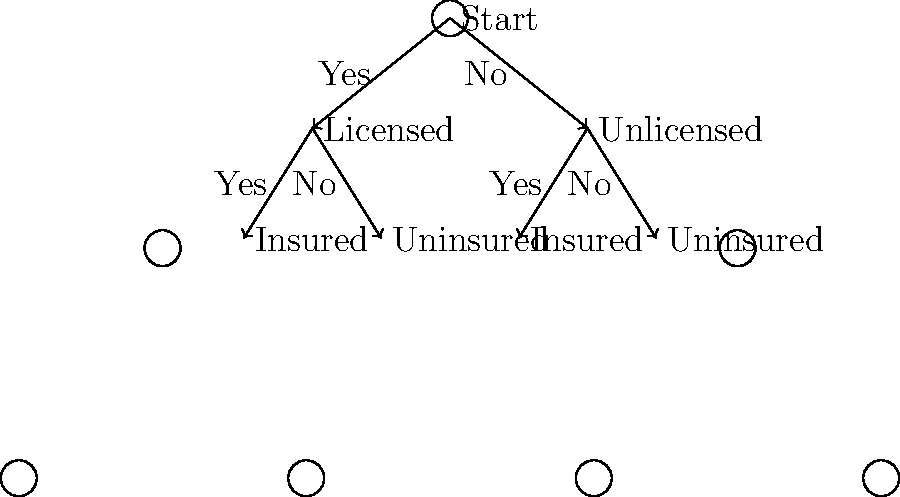Based on the decision tree for selecting trustworthy service providers, what is the optimal path to choose a provider, and how many criteria are considered in this selection process? To determine the optimal path and the number of criteria considered in the selection process, let's analyze the decision tree step-by-step:

1. The decision tree starts with two main criteria:
   a) Whether the service provider is licensed
   b) Whether the service provider is insured

2. The first decision point is about licensing:
   - If the provider is licensed, we move to the left branch
   - If the provider is unlicensed, we move to the right branch

3. The second decision point is about insurance:
   - For both licensed and unlicensed providers, we consider whether they are insured or not

4. The optimal path in this decision tree would be:
   Start → Licensed (Yes) → Insured (Yes)

5. This path ensures that we select a service provider who is both licensed and insured, which are typically the most important criteria for trustworthiness.

6. The number of criteria considered in this selection process is 2:
   a) Licensing status
   b) Insurance status

Therefore, the optimal path involves selecting a licensed and insured service provider, and the decision tree considers 2 criteria in the selection process.
Answer: Licensed and insured path; 2 criteria 